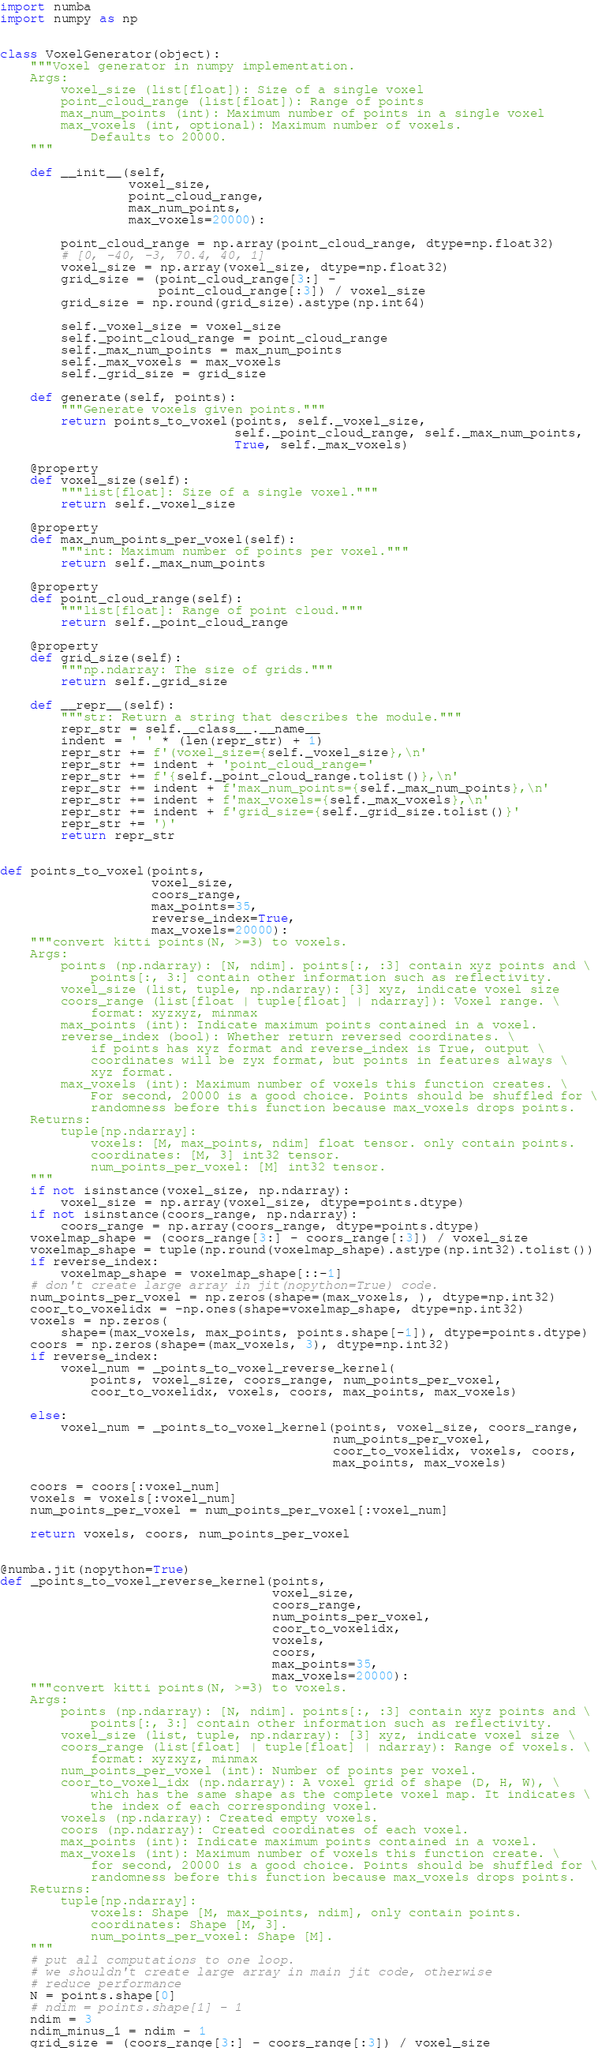Convert code to text. <code><loc_0><loc_0><loc_500><loc_500><_Python_>import numba
import numpy as np


class VoxelGenerator(object):
    """Voxel generator in numpy implementation.
    Args:
        voxel_size (list[float]): Size of a single voxel
        point_cloud_range (list[float]): Range of points
        max_num_points (int): Maximum number of points in a single voxel
        max_voxels (int, optional): Maximum number of voxels.
            Defaults to 20000.
    """

    def __init__(self,
                 voxel_size,
                 point_cloud_range,
                 max_num_points,
                 max_voxels=20000):

        point_cloud_range = np.array(point_cloud_range, dtype=np.float32)
        # [0, -40, -3, 70.4, 40, 1]
        voxel_size = np.array(voxel_size, dtype=np.float32)
        grid_size = (point_cloud_range[3:] -
                     point_cloud_range[:3]) / voxel_size
        grid_size = np.round(grid_size).astype(np.int64)

        self._voxel_size = voxel_size
        self._point_cloud_range = point_cloud_range
        self._max_num_points = max_num_points
        self._max_voxels = max_voxels
        self._grid_size = grid_size

    def generate(self, points):
        """Generate voxels given points."""
        return points_to_voxel(points, self._voxel_size,
                               self._point_cloud_range, self._max_num_points,
                               True, self._max_voxels)

    @property
    def voxel_size(self):
        """list[float]: Size of a single voxel."""
        return self._voxel_size

    @property
    def max_num_points_per_voxel(self):
        """int: Maximum number of points per voxel."""
        return self._max_num_points

    @property
    def point_cloud_range(self):
        """list[float]: Range of point cloud."""
        return self._point_cloud_range

    @property
    def grid_size(self):
        """np.ndarray: The size of grids."""
        return self._grid_size

    def __repr__(self):
        """str: Return a string that describes the module."""
        repr_str = self.__class__.__name__
        indent = ' ' * (len(repr_str) + 1)
        repr_str += f'(voxel_size={self._voxel_size},\n'
        repr_str += indent + 'point_cloud_range='
        repr_str += f'{self._point_cloud_range.tolist()},\n'
        repr_str += indent + f'max_num_points={self._max_num_points},\n'
        repr_str += indent + f'max_voxels={self._max_voxels},\n'
        repr_str += indent + f'grid_size={self._grid_size.tolist()}'
        repr_str += ')'
        return repr_str


def points_to_voxel(points,
                    voxel_size,
                    coors_range,
                    max_points=35,
                    reverse_index=True,
                    max_voxels=20000):
    """convert kitti points(N, >=3) to voxels.
    Args:
        points (np.ndarray): [N, ndim]. points[:, :3] contain xyz points and \
            points[:, 3:] contain other information such as reflectivity.
        voxel_size (list, tuple, np.ndarray): [3] xyz, indicate voxel size
        coors_range (list[float | tuple[float] | ndarray]): Voxel range. \
            format: xyzxyz, minmax
        max_points (int): Indicate maximum points contained in a voxel.
        reverse_index (bool): Whether return reversed coordinates. \
            if points has xyz format and reverse_index is True, output \
            coordinates will be zyx format, but points in features always \
            xyz format.
        max_voxels (int): Maximum number of voxels this function creates. \
            For second, 20000 is a good choice. Points should be shuffled for \
            randomness before this function because max_voxels drops points.
    Returns:
        tuple[np.ndarray]:
            voxels: [M, max_points, ndim] float tensor. only contain points.
            coordinates: [M, 3] int32 tensor.
            num_points_per_voxel: [M] int32 tensor.
    """
    if not isinstance(voxel_size, np.ndarray):
        voxel_size = np.array(voxel_size, dtype=points.dtype)
    if not isinstance(coors_range, np.ndarray):
        coors_range = np.array(coors_range, dtype=points.dtype)
    voxelmap_shape = (coors_range[3:] - coors_range[:3]) / voxel_size
    voxelmap_shape = tuple(np.round(voxelmap_shape).astype(np.int32).tolist())
    if reverse_index:
        voxelmap_shape = voxelmap_shape[::-1]
    # don't create large array in jit(nopython=True) code.
    num_points_per_voxel = np.zeros(shape=(max_voxels, ), dtype=np.int32)
    coor_to_voxelidx = -np.ones(shape=voxelmap_shape, dtype=np.int32)
    voxels = np.zeros(
        shape=(max_voxels, max_points, points.shape[-1]), dtype=points.dtype)
    coors = np.zeros(shape=(max_voxels, 3), dtype=np.int32)
    if reverse_index:
        voxel_num = _points_to_voxel_reverse_kernel(
            points, voxel_size, coors_range, num_points_per_voxel,
            coor_to_voxelidx, voxels, coors, max_points, max_voxels)

    else:
        voxel_num = _points_to_voxel_kernel(points, voxel_size, coors_range,
                                            num_points_per_voxel,
                                            coor_to_voxelidx, voxels, coors,
                                            max_points, max_voxels)

    coors = coors[:voxel_num]
    voxels = voxels[:voxel_num]
    num_points_per_voxel = num_points_per_voxel[:voxel_num]

    return voxels, coors, num_points_per_voxel


@numba.jit(nopython=True)
def _points_to_voxel_reverse_kernel(points,
                                    voxel_size,
                                    coors_range,
                                    num_points_per_voxel,
                                    coor_to_voxelidx,
                                    voxels,
                                    coors,
                                    max_points=35,
                                    max_voxels=20000):
    """convert kitti points(N, >=3) to voxels.
    Args:
        points (np.ndarray): [N, ndim]. points[:, :3] contain xyz points and \
            points[:, 3:] contain other information such as reflectivity.
        voxel_size (list, tuple, np.ndarray): [3] xyz, indicate voxel size \
        coors_range (list[float] | tuple[float] | ndarray): Range of voxels. \
            format: xyzxyz, minmax
        num_points_per_voxel (int): Number of points per voxel.
        coor_to_voxel_idx (np.ndarray): A voxel grid of shape (D, H, W), \
            which has the same shape as the complete voxel map. It indicates \
            the index of each corresponding voxel.
        voxels (np.ndarray): Created empty voxels.
        coors (np.ndarray): Created coordinates of each voxel.
        max_points (int): Indicate maximum points contained in a voxel.
        max_voxels (int): Maximum number of voxels this function create. \
            for second, 20000 is a good choice. Points should be shuffled for \
            randomness before this function because max_voxels drops points.
    Returns:
        tuple[np.ndarray]:
            voxels: Shape [M, max_points, ndim], only contain points.
            coordinates: Shape [M, 3].
            num_points_per_voxel: Shape [M].
    """
    # put all computations to one loop.
    # we shouldn't create large array in main jit code, otherwise
    # reduce performance
    N = points.shape[0]
    # ndim = points.shape[1] - 1
    ndim = 3
    ndim_minus_1 = ndim - 1
    grid_size = (coors_range[3:] - coors_range[:3]) / voxel_size</code> 